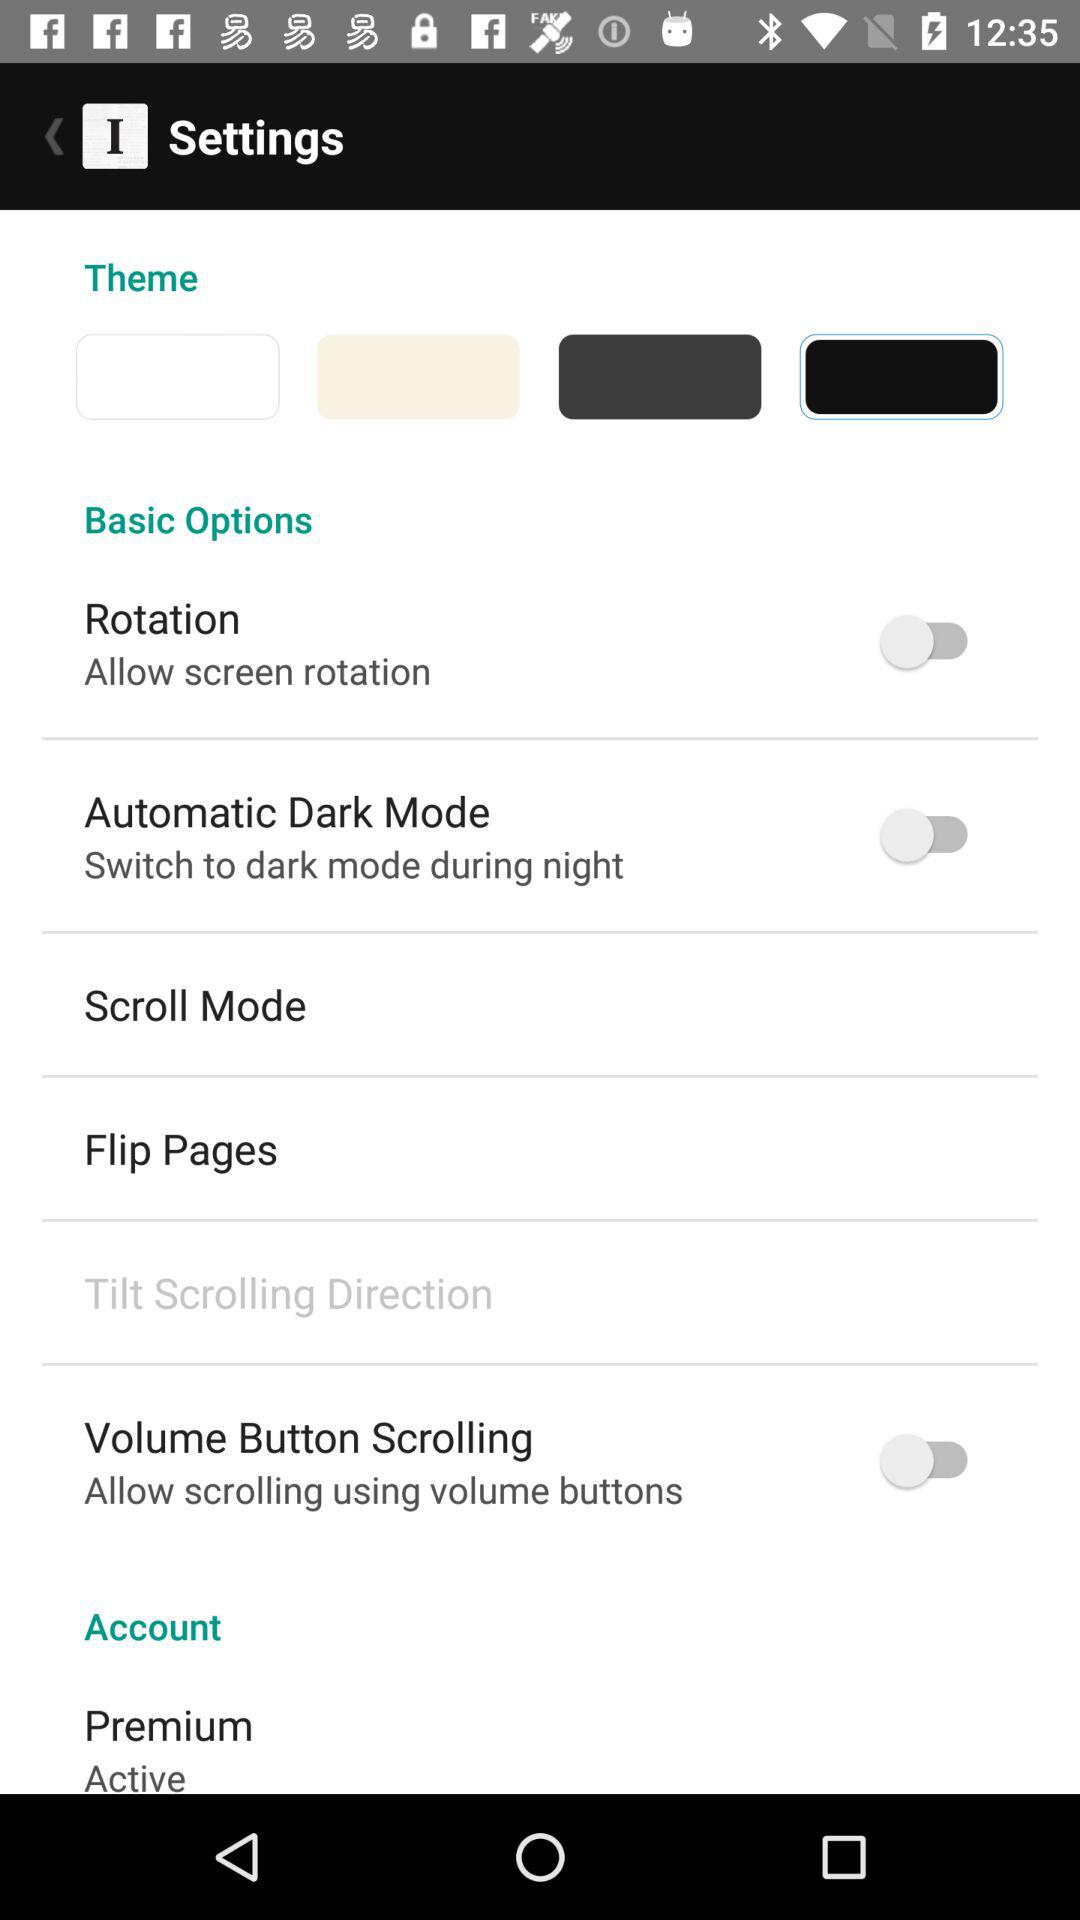What is the status of "Rotation"? The status of "Rotation" is "off". 